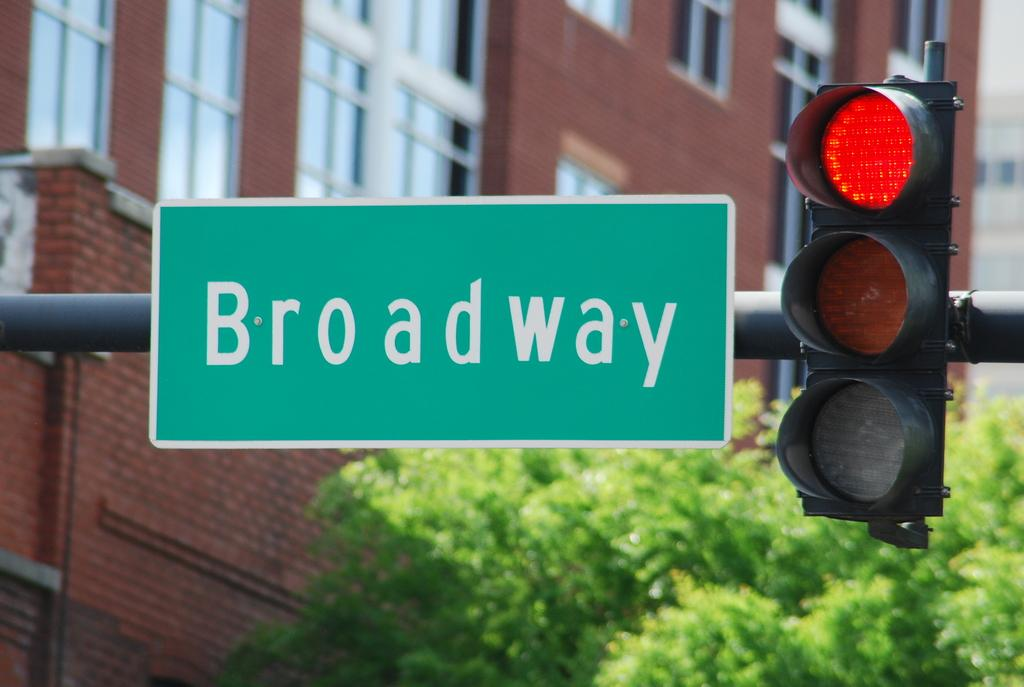What is the main object in the center of the image? There is a sign board and a traffic light in the center of the image. Can you describe the background of the image? There are buildings, windows, trees, and other unspecified objects in the background of the image. What type of drain is visible in the image? There is no drain present in the image. Can you tell me the name of the brother who lives in the town depicted in the image? There is no town or brother mentioned in the image; it only features a sign board, a traffic light, and various elements in the background. 